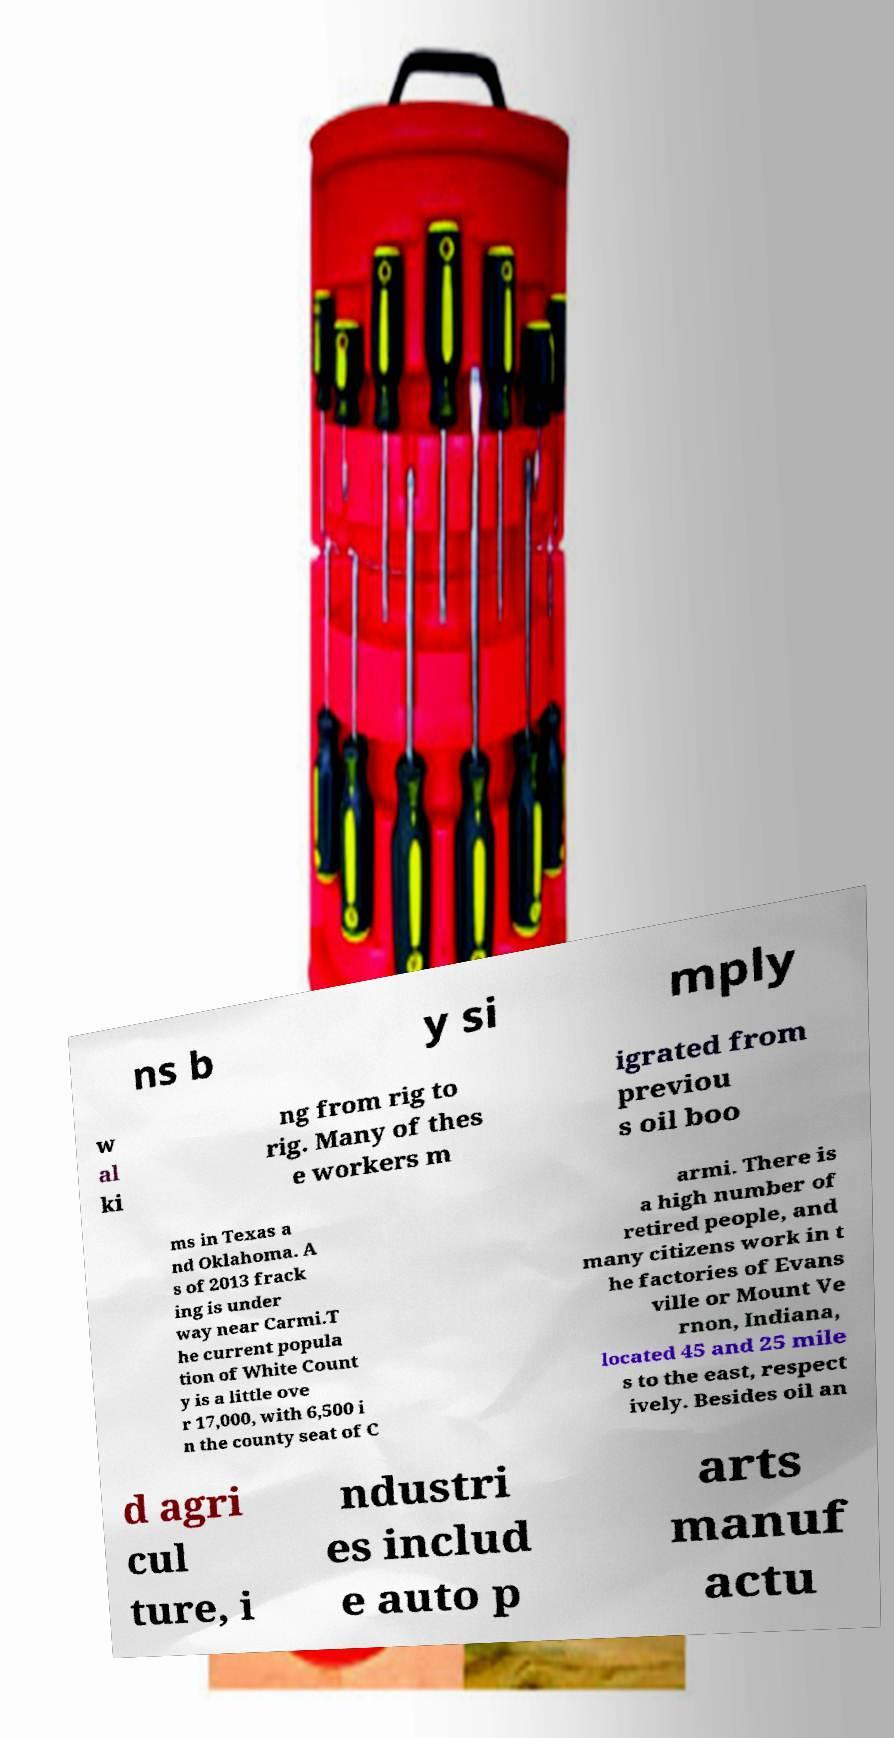What messages or text are displayed in this image? I need them in a readable, typed format. ns b y si mply w al ki ng from rig to rig. Many of thes e workers m igrated from previou s oil boo ms in Texas a nd Oklahoma. A s of 2013 frack ing is under way near Carmi.T he current popula tion of White Count y is a little ove r 17,000, with 6,500 i n the county seat of C armi. There is a high number of retired people, and many citizens work in t he factories of Evans ville or Mount Ve rnon, Indiana, located 45 and 25 mile s to the east, respect ively. Besides oil an d agri cul ture, i ndustri es includ e auto p arts manuf actu 